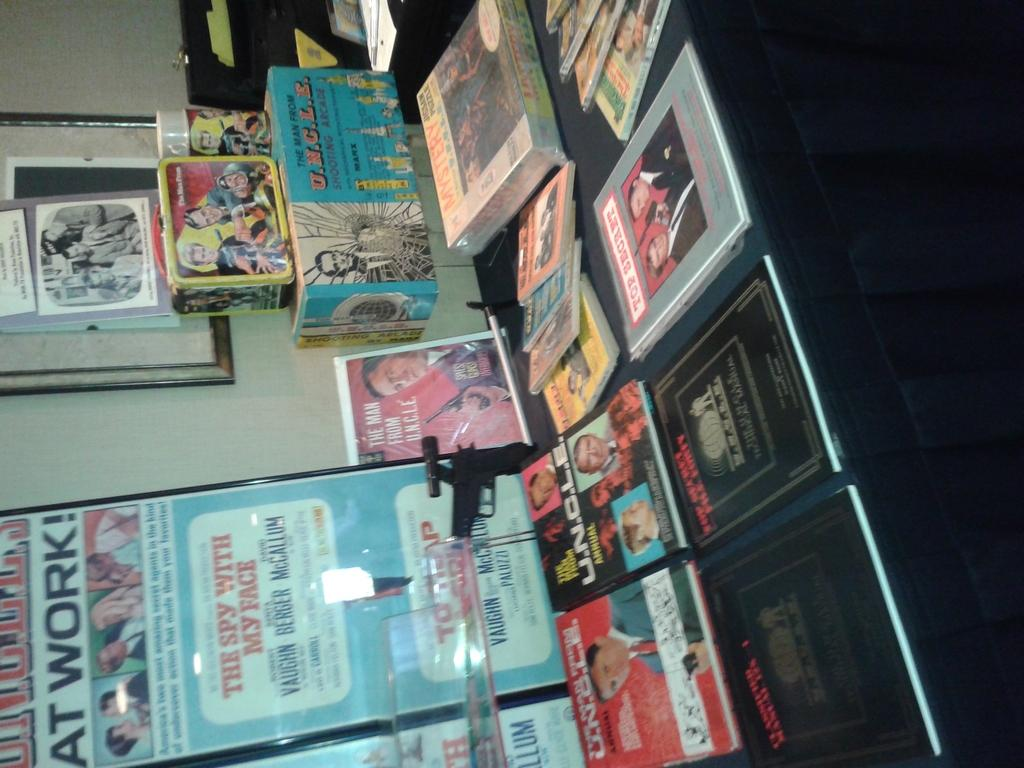Provide a one-sentence caption for the provided image. Book fair with an ad in the back that says "The Spy with My Face". 